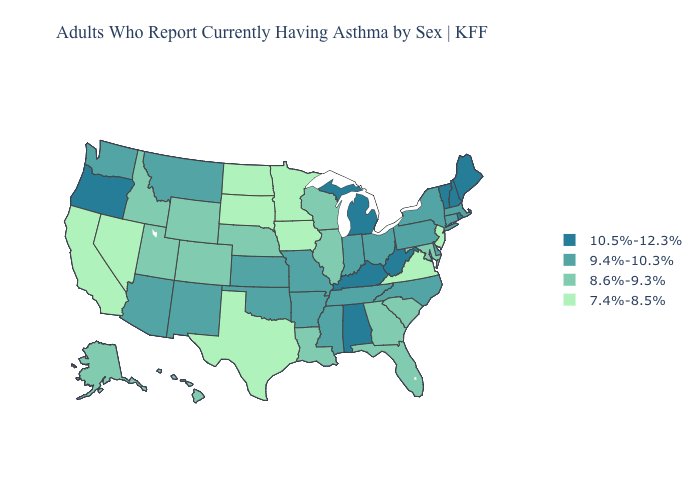Is the legend a continuous bar?
Answer briefly. No. Which states hav the highest value in the West?
Keep it brief. Oregon. Does the map have missing data?
Concise answer only. No. What is the lowest value in the Northeast?
Be succinct. 7.4%-8.5%. Name the states that have a value in the range 10.5%-12.3%?
Short answer required. Alabama, Kentucky, Maine, Michigan, New Hampshire, Oregon, Rhode Island, Vermont, West Virginia. Among the states that border Oregon , which have the lowest value?
Quick response, please. California, Nevada. What is the highest value in the USA?
Short answer required. 10.5%-12.3%. How many symbols are there in the legend?
Write a very short answer. 4. What is the highest value in the USA?
Give a very brief answer. 10.5%-12.3%. Is the legend a continuous bar?
Be succinct. No. Does the map have missing data?
Quick response, please. No. What is the value of North Dakota?
Be succinct. 7.4%-8.5%. Which states have the highest value in the USA?
Write a very short answer. Alabama, Kentucky, Maine, Michigan, New Hampshire, Oregon, Rhode Island, Vermont, West Virginia. Does Idaho have a lower value than South Carolina?
Be succinct. No. Name the states that have a value in the range 9.4%-10.3%?
Keep it brief. Arizona, Arkansas, Connecticut, Delaware, Indiana, Kansas, Massachusetts, Mississippi, Missouri, Montana, New Mexico, New York, North Carolina, Ohio, Oklahoma, Pennsylvania, Tennessee, Washington. 